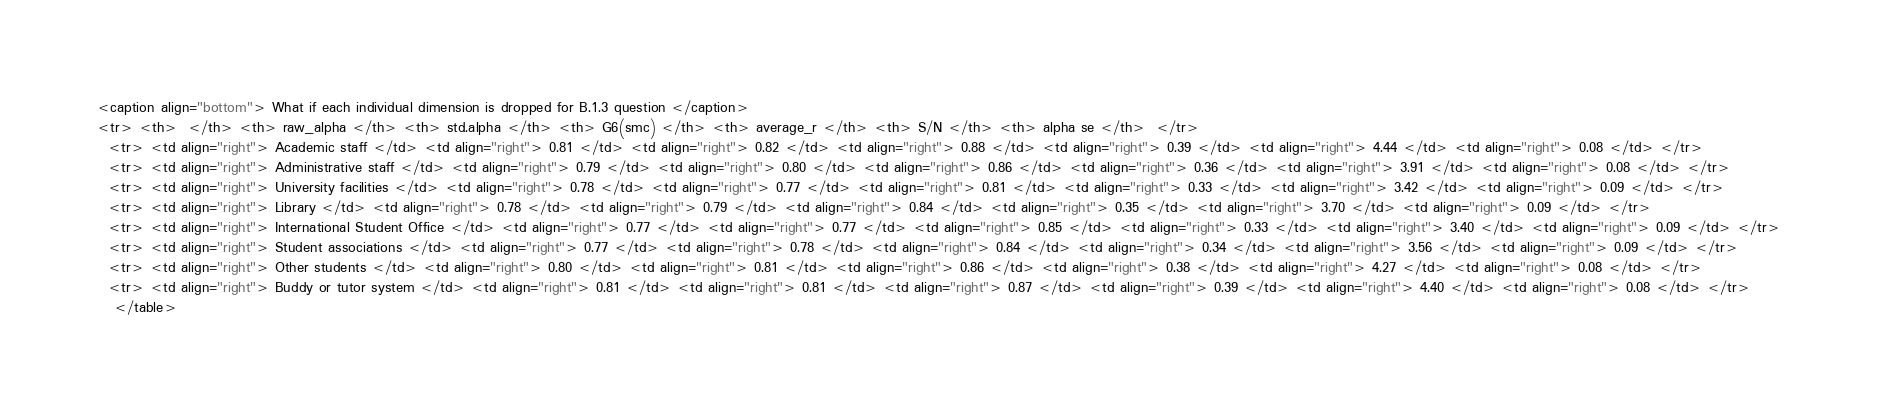<code> <loc_0><loc_0><loc_500><loc_500><_HTML_><caption align="bottom"> What if each individual dimension is dropped for B.1.3 question </caption>
<tr> <th>  </th> <th> raw_alpha </th> <th> std.alpha </th> <th> G6(smc) </th> <th> average_r </th> <th> S/N </th> <th> alpha se </th>  </tr>
  <tr> <td align="right"> Academic staff </td> <td align="right"> 0.81 </td> <td align="right"> 0.82 </td> <td align="right"> 0.88 </td> <td align="right"> 0.39 </td> <td align="right"> 4.44 </td> <td align="right"> 0.08 </td> </tr>
  <tr> <td align="right"> Administrative staff </td> <td align="right"> 0.79 </td> <td align="right"> 0.80 </td> <td align="right"> 0.86 </td> <td align="right"> 0.36 </td> <td align="right"> 3.91 </td> <td align="right"> 0.08 </td> </tr>
  <tr> <td align="right"> University facilities </td> <td align="right"> 0.78 </td> <td align="right"> 0.77 </td> <td align="right"> 0.81 </td> <td align="right"> 0.33 </td> <td align="right"> 3.42 </td> <td align="right"> 0.09 </td> </tr>
  <tr> <td align="right"> Library </td> <td align="right"> 0.78 </td> <td align="right"> 0.79 </td> <td align="right"> 0.84 </td> <td align="right"> 0.35 </td> <td align="right"> 3.70 </td> <td align="right"> 0.09 </td> </tr>
  <tr> <td align="right"> International Student Office </td> <td align="right"> 0.77 </td> <td align="right"> 0.77 </td> <td align="right"> 0.85 </td> <td align="right"> 0.33 </td> <td align="right"> 3.40 </td> <td align="right"> 0.09 </td> </tr>
  <tr> <td align="right"> Student associations </td> <td align="right"> 0.77 </td> <td align="right"> 0.78 </td> <td align="right"> 0.84 </td> <td align="right"> 0.34 </td> <td align="right"> 3.56 </td> <td align="right"> 0.09 </td> </tr>
  <tr> <td align="right"> Other students </td> <td align="right"> 0.80 </td> <td align="right"> 0.81 </td> <td align="right"> 0.86 </td> <td align="right"> 0.38 </td> <td align="right"> 4.27 </td> <td align="right"> 0.08 </td> </tr>
  <tr> <td align="right"> Buddy or tutor system </td> <td align="right"> 0.81 </td> <td align="right"> 0.81 </td> <td align="right"> 0.87 </td> <td align="right"> 0.39 </td> <td align="right"> 4.40 </td> <td align="right"> 0.08 </td> </tr>
   </table>
</code> 